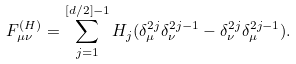<formula> <loc_0><loc_0><loc_500><loc_500>F _ { \mu \nu } ^ { ( H ) } = \sum _ { j = 1 } ^ { [ d / 2 ] - 1 } H _ { j } ( \delta _ { \mu } ^ { 2 j } \delta _ { \nu } ^ { 2 j - 1 } - \delta _ { \nu } ^ { 2 j } \delta _ { \mu } ^ { 2 j - 1 } ) .</formula> 